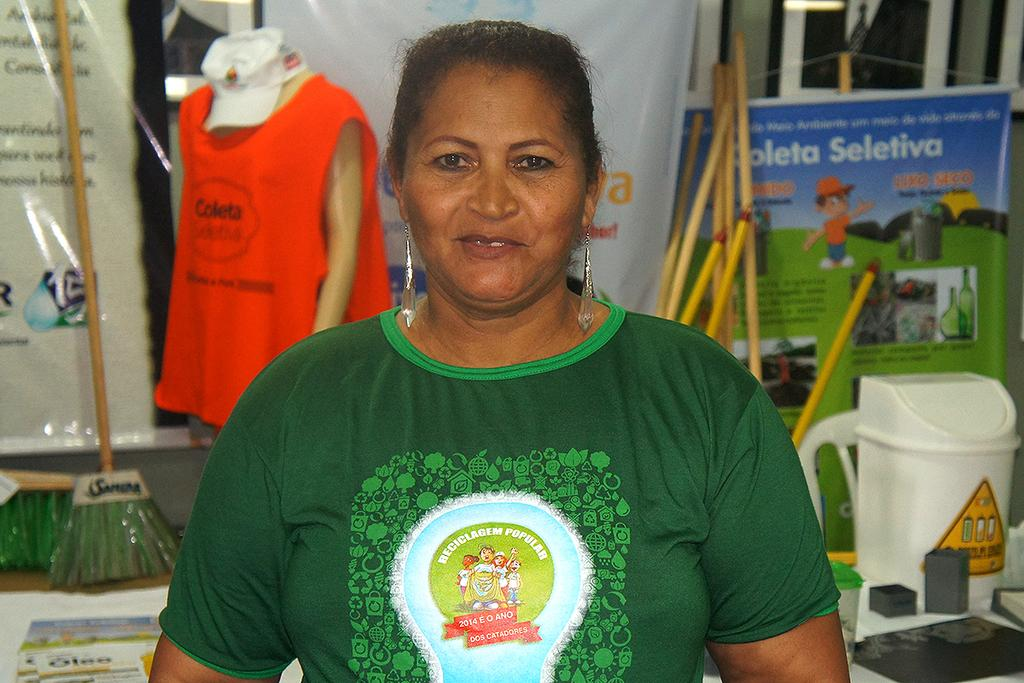Who is present in the image? There is a woman in the image. What is the woman's expression? The woman is smiling. What can be seen in the background of the image? There is a mannequin, cloth, a cap, banners, sticks, a groom stick, a bucket, and other objects in the background of the image. What type of door can be seen in the image? There is no door present in the image. What type of suit is the mannequin wearing in the image? There is no mannequin wearing a suit in the image; the mannequin is not wearing any clothing. 